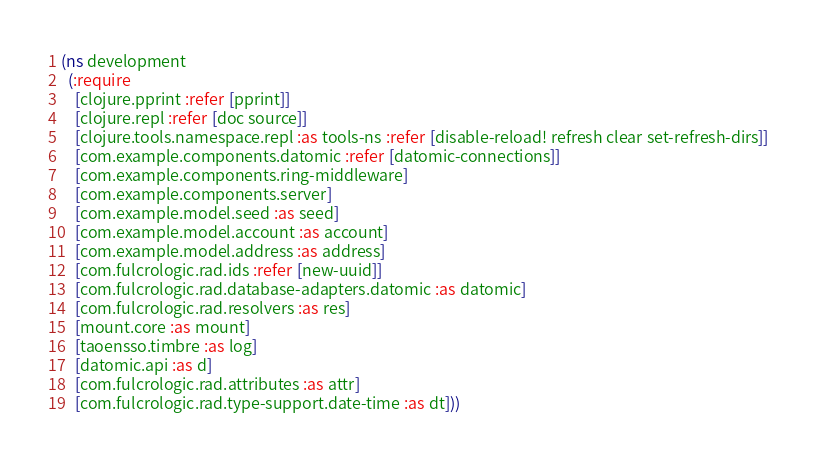<code> <loc_0><loc_0><loc_500><loc_500><_Clojure_>(ns development
  (:require
    [clojure.pprint :refer [pprint]]
    [clojure.repl :refer [doc source]]
    [clojure.tools.namespace.repl :as tools-ns :refer [disable-reload! refresh clear set-refresh-dirs]]
    [com.example.components.datomic :refer [datomic-connections]]
    [com.example.components.ring-middleware]
    [com.example.components.server]
    [com.example.model.seed :as seed]
    [com.example.model.account :as account]
    [com.example.model.address :as address]
    [com.fulcrologic.rad.ids :refer [new-uuid]]
    [com.fulcrologic.rad.database-adapters.datomic :as datomic]
    [com.fulcrologic.rad.resolvers :as res]
    [mount.core :as mount]
    [taoensso.timbre :as log]
    [datomic.api :as d]
    [com.fulcrologic.rad.attributes :as attr]
    [com.fulcrologic.rad.type-support.date-time :as dt]))
</code> 